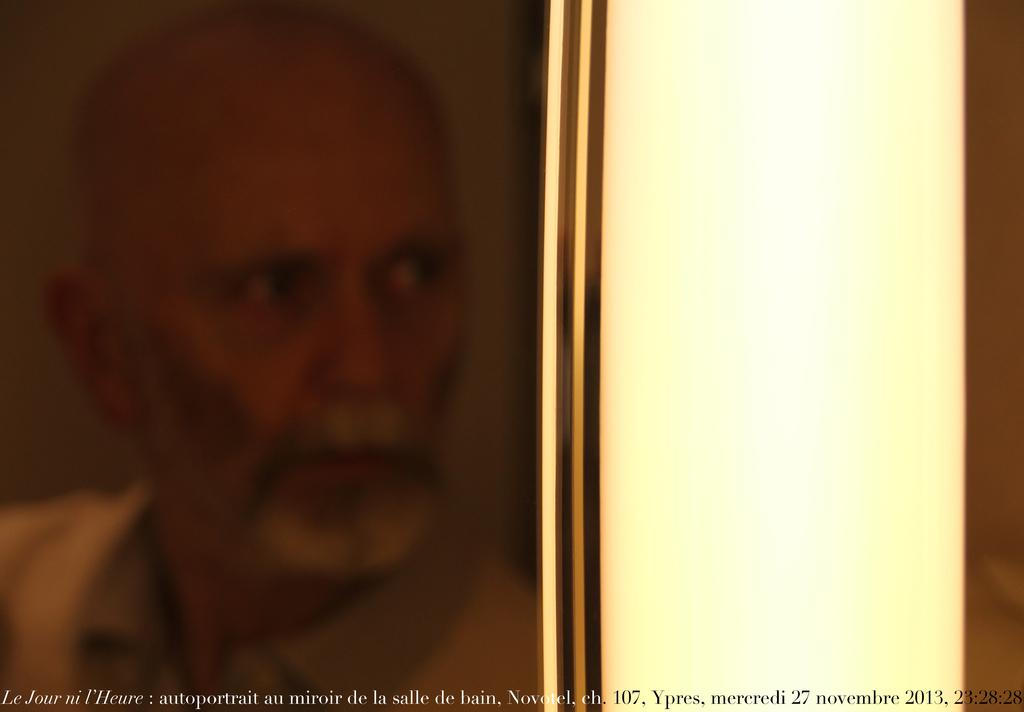What is the main subject of the image? There is a person's frame in the image. What can be seen on the right side of the image? There is a wall on the right side of the image. Where is the text located in the image? The text is at the bottom of the image. How does the person's frame process dust in the image? The person's frame does not process dust in the image, as it is a static image and not a functioning object. 